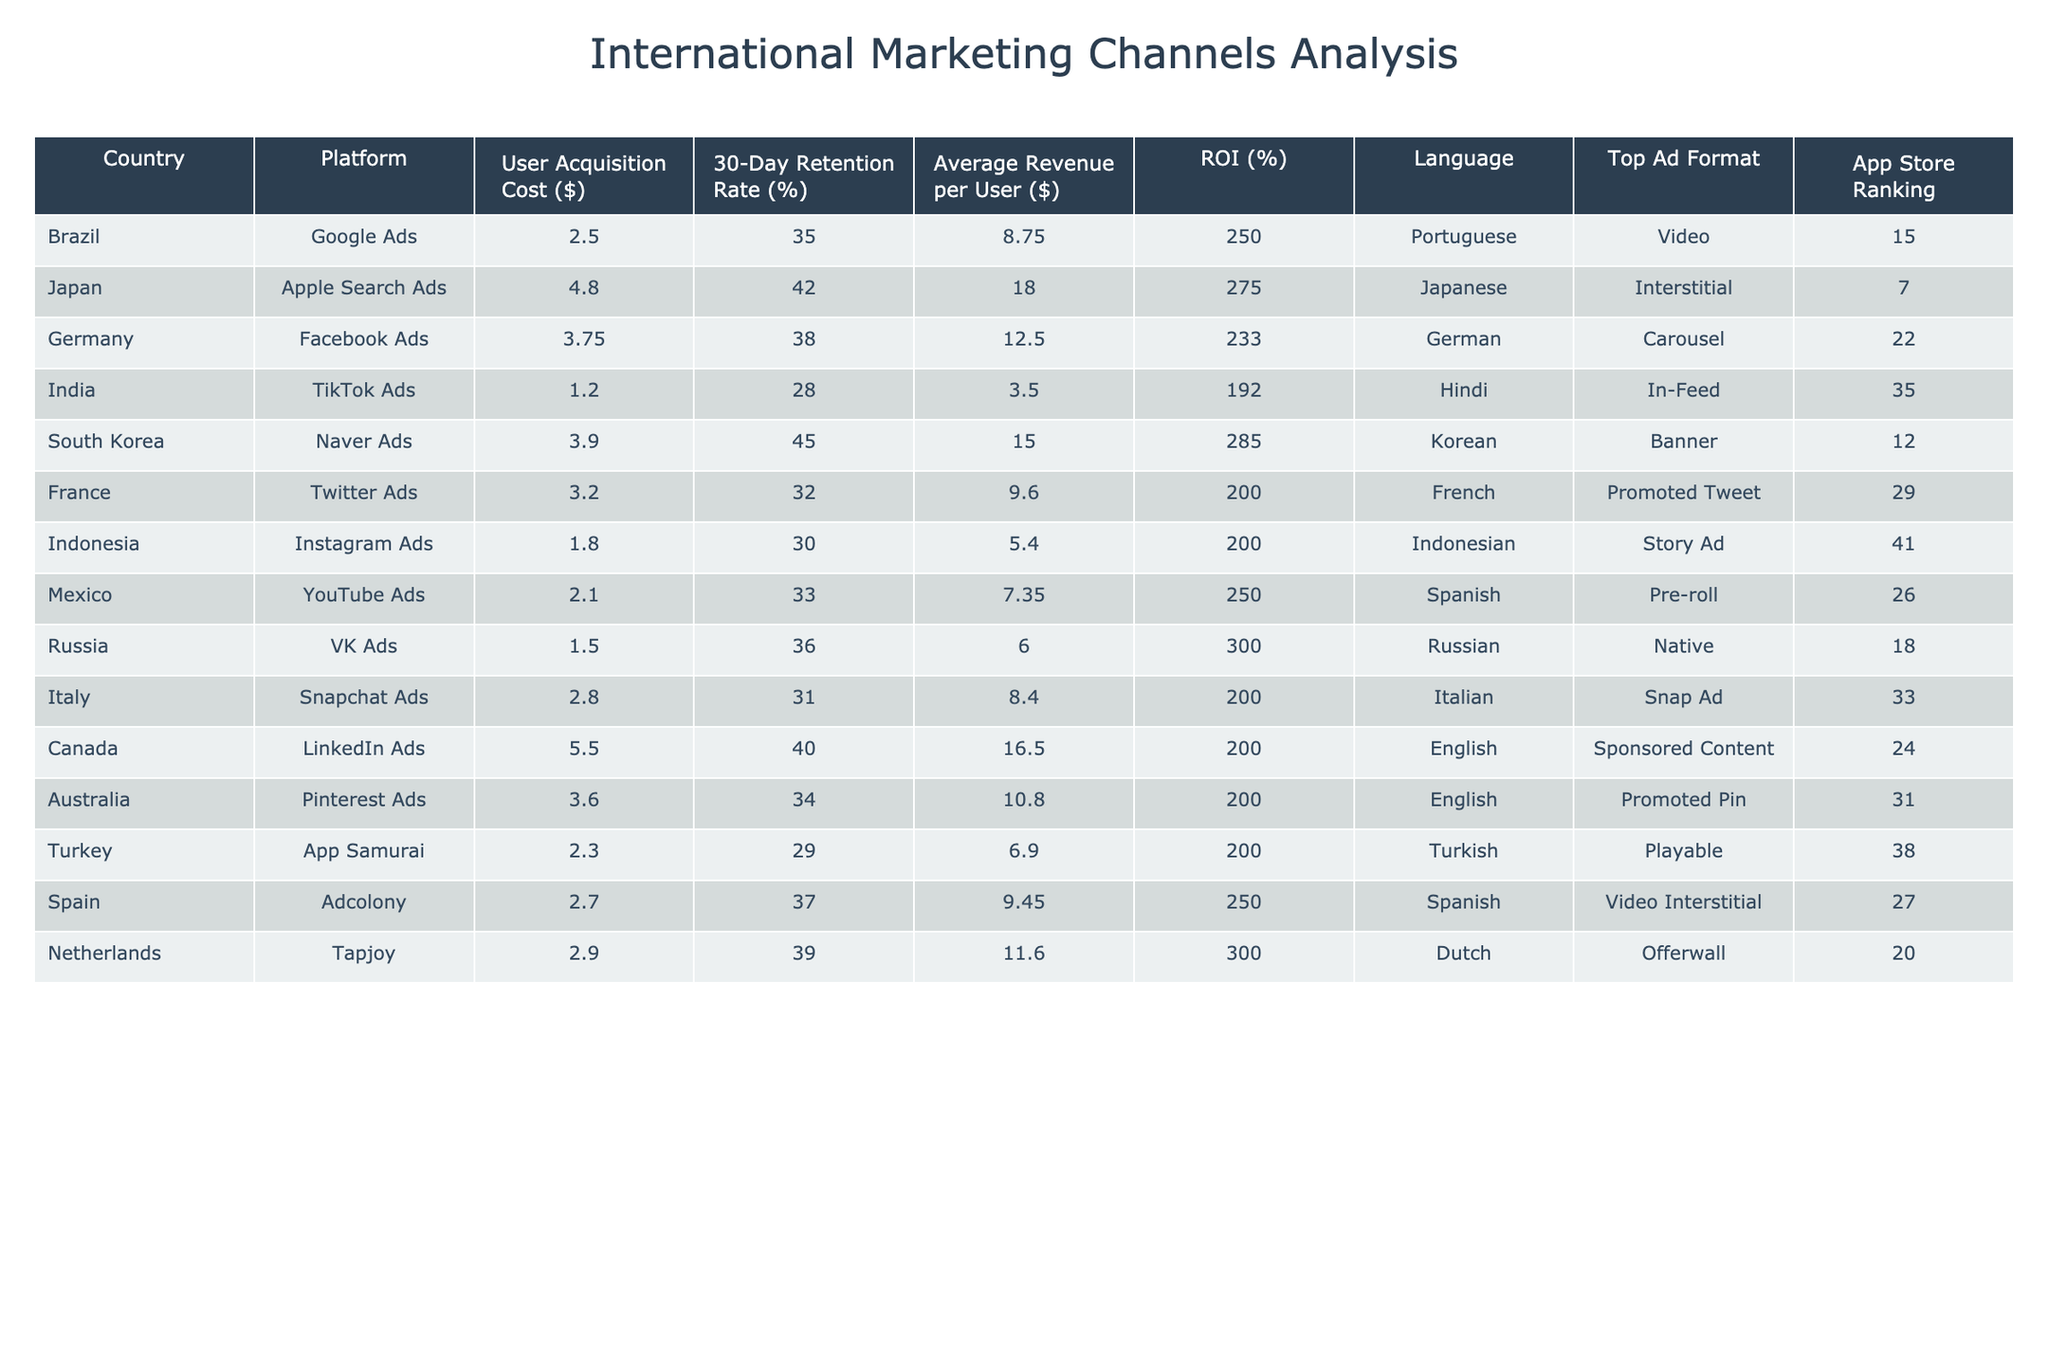What is the User Acquisition Cost for TikTok Ads in India? The table lists the User Acquisition Cost for TikTok Ads in India as $1.20.
Answer: $1.20 What is the 30-Day Retention Rate for users acquired through Twitter Ads in France? According to the table, the 30-Day Retention Rate for Twitter Ads in France is 32%.
Answer: 32% Which platform has the highest Average Revenue per User? By examining the Average Revenue per User column, we see that Naver Ads in South Korea has the highest value at $15.00.
Answer: $15.00 What is the total ROI (%) for all platforms combined? To find the total ROI, we sum up all individual ROI percentages: (250 + 275 + 233 + 192 + 285 + 200 + 200 + 300 + 200 + 200 + 200 + 250 + 300) and then divide by the number of countries (13). This results in 234.23.
Answer: 234.23% Is the User Acquisition Cost for Facebook Ads in Germany greater than $3.50? Looking at the table, the User Acquisition Cost for Facebook Ads in Germany is $3.75, which is indeed greater than $3.50.
Answer: Yes Which country has the lowest User Acquisition Cost and what is that cost? The table indicates that India has the lowest User Acquisition Cost at $1.20 through TikTok Ads.
Answer: $1.20 What is the difference in 30-Day Retention Rates between Instagram Ads in Indonesia and Apple Search Ads in Japan? The 30-Day Retention Rate for Instagram Ads in Indonesia is 30%, while for Apple Search Ads in Japan it is 42%. The difference is 42 - 30 = 12%.
Answer: 12% Which marketing channel has a higher ROI: VK Ads in Russia or Snap Ads in Italy? VK Ads has an ROI of 300% while Snap Ads has 200%. Therefore, VK Ads has a higher ROI.
Answer: VK Ads If you were to average the Average Revenue per User across all countries, what would it be? Summing the Average Revenue per User values (8.75 + 18.00 + 12.50 + 3.50 + 15.00 + 9.60 + 5.40 + 7.35 + 6.00 + 8.40 + 16.50 + 10.80 + 11.60) gives  10.90, dividing this by 13 gives an average of approximately $10.90.
Answer: $10.90 Is it true that all marketing channels have a 30-Day Retention Rate above 25%? Upon reviewing the table, TikTok Ads in India has a 30-Day Retention Rate of 28%, while it also notes that users acquired in Turkey via App Samurai have a retention rate of 29%. Both rates are above 25%. Thus, this statement is true.
Answer: Yes Which platform has the highest User Acquisition Cost and which country is it associated with? By examining the User Acquisition Cost column, it is determined that LinkedIn Ads in Canada have the highest cost at $5.50.
Answer: LinkedIn Ads in Canada 